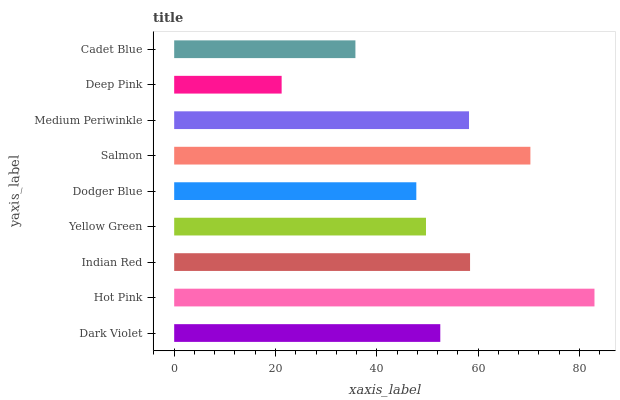Is Deep Pink the minimum?
Answer yes or no. Yes. Is Hot Pink the maximum?
Answer yes or no. Yes. Is Indian Red the minimum?
Answer yes or no. No. Is Indian Red the maximum?
Answer yes or no. No. Is Hot Pink greater than Indian Red?
Answer yes or no. Yes. Is Indian Red less than Hot Pink?
Answer yes or no. Yes. Is Indian Red greater than Hot Pink?
Answer yes or no. No. Is Hot Pink less than Indian Red?
Answer yes or no. No. Is Dark Violet the high median?
Answer yes or no. Yes. Is Dark Violet the low median?
Answer yes or no. Yes. Is Yellow Green the high median?
Answer yes or no. No. Is Dodger Blue the low median?
Answer yes or no. No. 